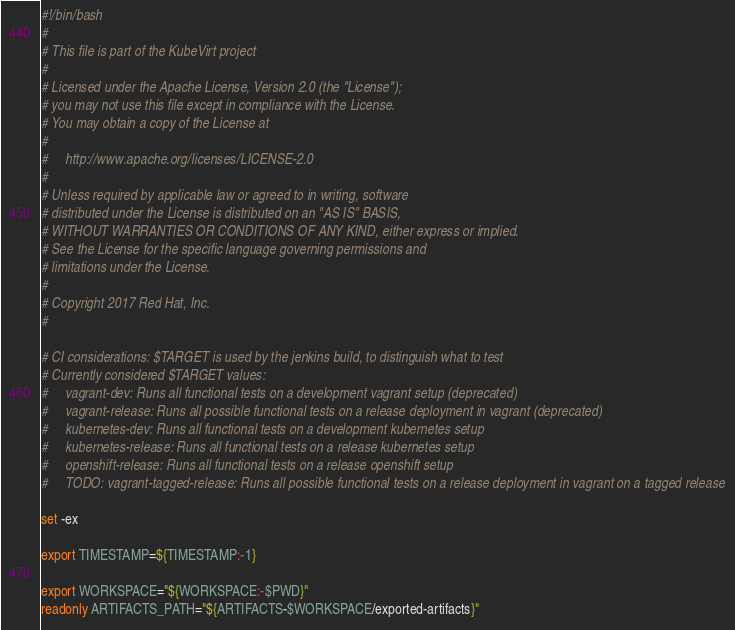Convert code to text. <code><loc_0><loc_0><loc_500><loc_500><_Bash_>#!/bin/bash
#
# This file is part of the KubeVirt project
#
# Licensed under the Apache License, Version 2.0 (the "License");
# you may not use this file except in compliance with the License.
# You may obtain a copy of the License at
#
#     http://www.apache.org/licenses/LICENSE-2.0
#
# Unless required by applicable law or agreed to in writing, software
# distributed under the License is distributed on an "AS IS" BASIS,
# WITHOUT WARRANTIES OR CONDITIONS OF ANY KIND, either express or implied.
# See the License for the specific language governing permissions and
# limitations under the License.
#
# Copyright 2017 Red Hat, Inc.
#

# CI considerations: $TARGET is used by the jenkins build, to distinguish what to test
# Currently considered $TARGET values:
#     vagrant-dev: Runs all functional tests on a development vagrant setup (deprecated)
#     vagrant-release: Runs all possible functional tests on a release deployment in vagrant (deprecated)
#     kubernetes-dev: Runs all functional tests on a development kubernetes setup
#     kubernetes-release: Runs all functional tests on a release kubernetes setup
#     openshift-release: Runs all functional tests on a release openshift setup
#     TODO: vagrant-tagged-release: Runs all possible functional tests on a release deployment in vagrant on a tagged release

set -ex

export TIMESTAMP=${TIMESTAMP:-1}

export WORKSPACE="${WORKSPACE:-$PWD}"
readonly ARTIFACTS_PATH="${ARTIFACTS-$WORKSPACE/exported-artifacts}"</code> 